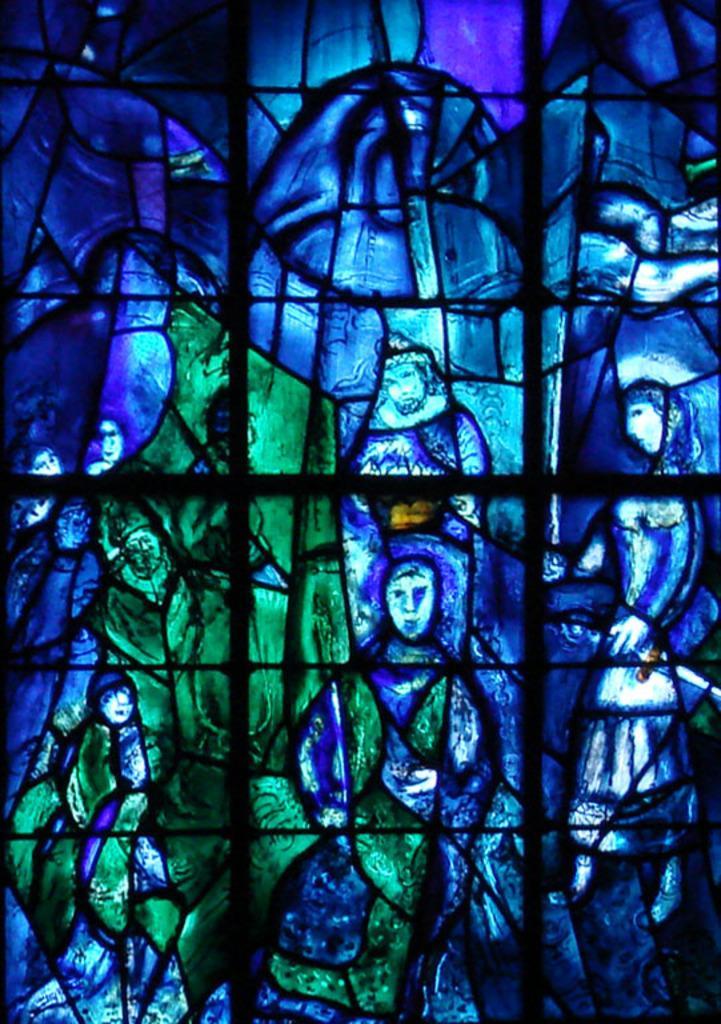In one or two sentences, can you explain what this image depicts? In this image we can see art which is in blue and green color on the glass. 